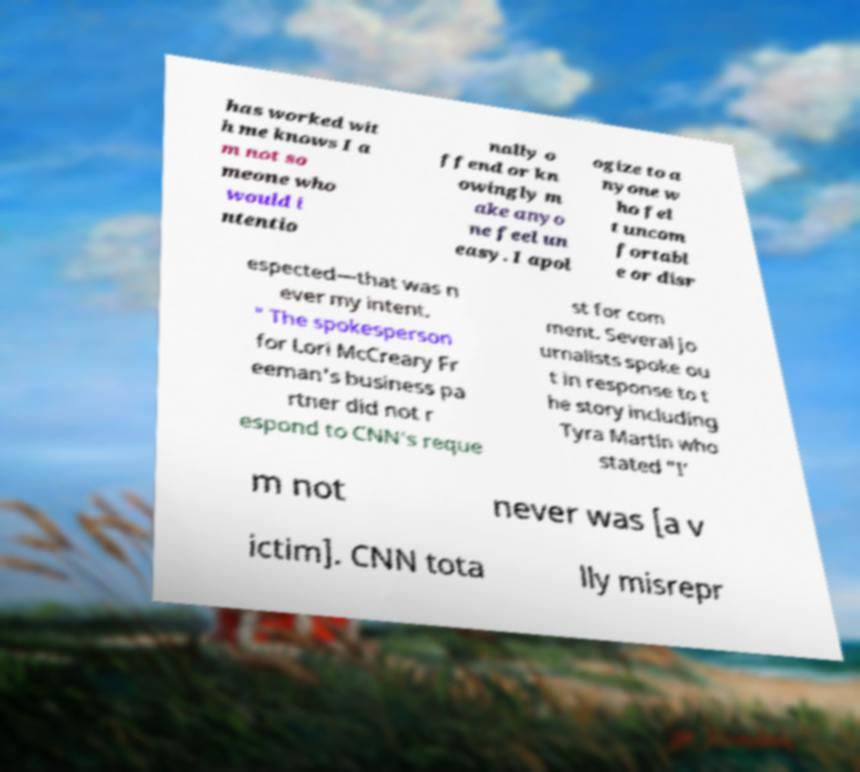Can you read and provide the text displayed in the image?This photo seems to have some interesting text. Can you extract and type it out for me? has worked wit h me knows I a m not so meone who would i ntentio nally o ffend or kn owingly m ake anyo ne feel un easy. I apol ogize to a nyone w ho fel t uncom fortabl e or disr espected—that was n ever my intent. " The spokesperson for Lori McCreary Fr eeman's business pa rtner did not r espond to CNN's reque st for com ment. Several jo urnalists spoke ou t in response to t he story including Tyra Martin who stated "I’ m not never was [a v ictim]. CNN tota lly misrepr 